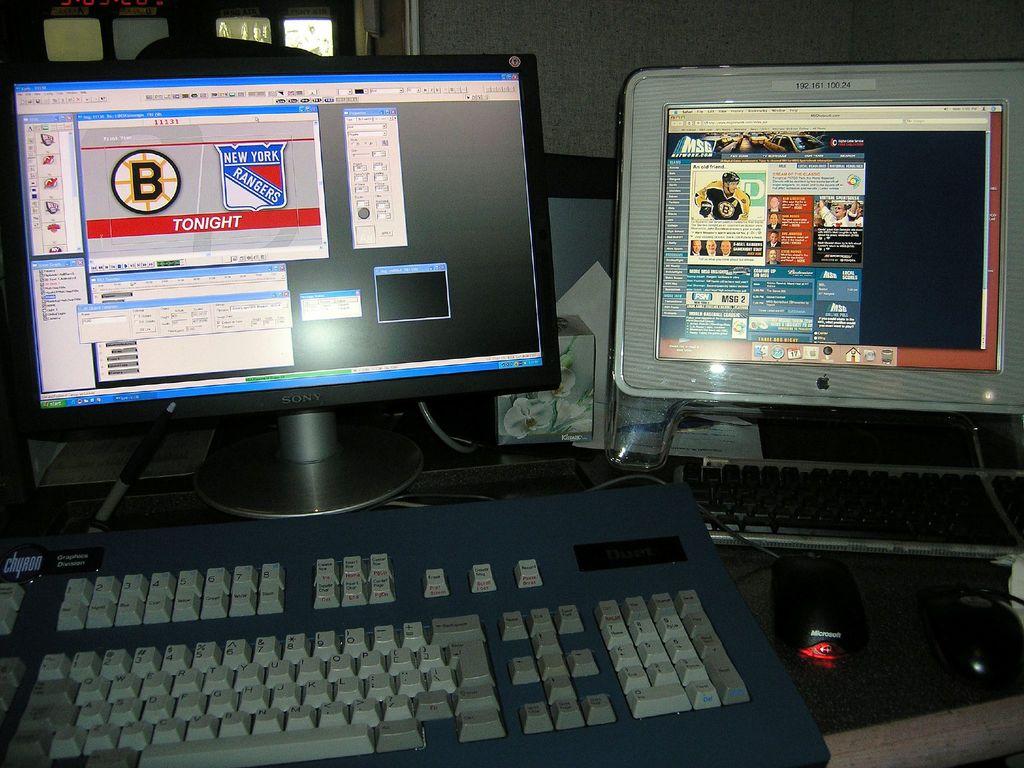What team is playing against boston?
Your answer should be very brief. New york. When is the game?
Ensure brevity in your answer.  Tonight. 